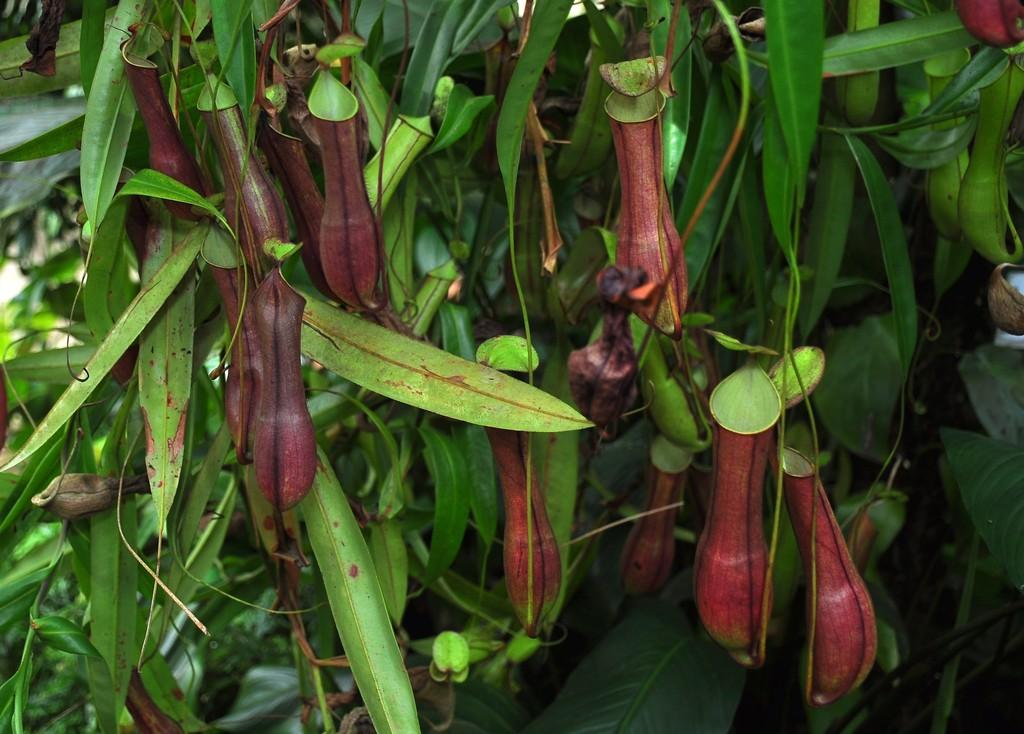What can be seen in the foreground of the image? There are trees in the foreground of the image. How would you describe the background of the image? The background of the image is blurred. What type of air is causing a shock to the trees in the image? There is no indication of air or shock in the image; it simply features trees in the foreground and a blurred background. 